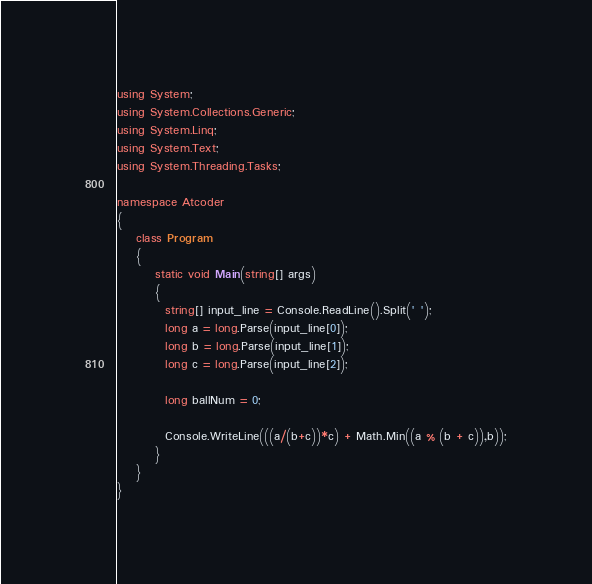<code> <loc_0><loc_0><loc_500><loc_500><_C#_>using System;
using System.Collections.Generic;
using System.Linq;
using System.Text;
using System.Threading.Tasks;
 
namespace Atcoder
{
    class Program
    {
        static void Main(string[] args)
        {
          string[] input_line = Console.ReadLine().Split(' ');
          long a = long.Parse(input_line[0]);
          long b = long.Parse(input_line[1]);
          long c = long.Parse(input_line[2]);
          
          long ballNum = 0;
          
          Console.WriteLine(((a/(b+c))*c) + Math.Min((a % (b + c)),b));
        }
    }
}
</code> 